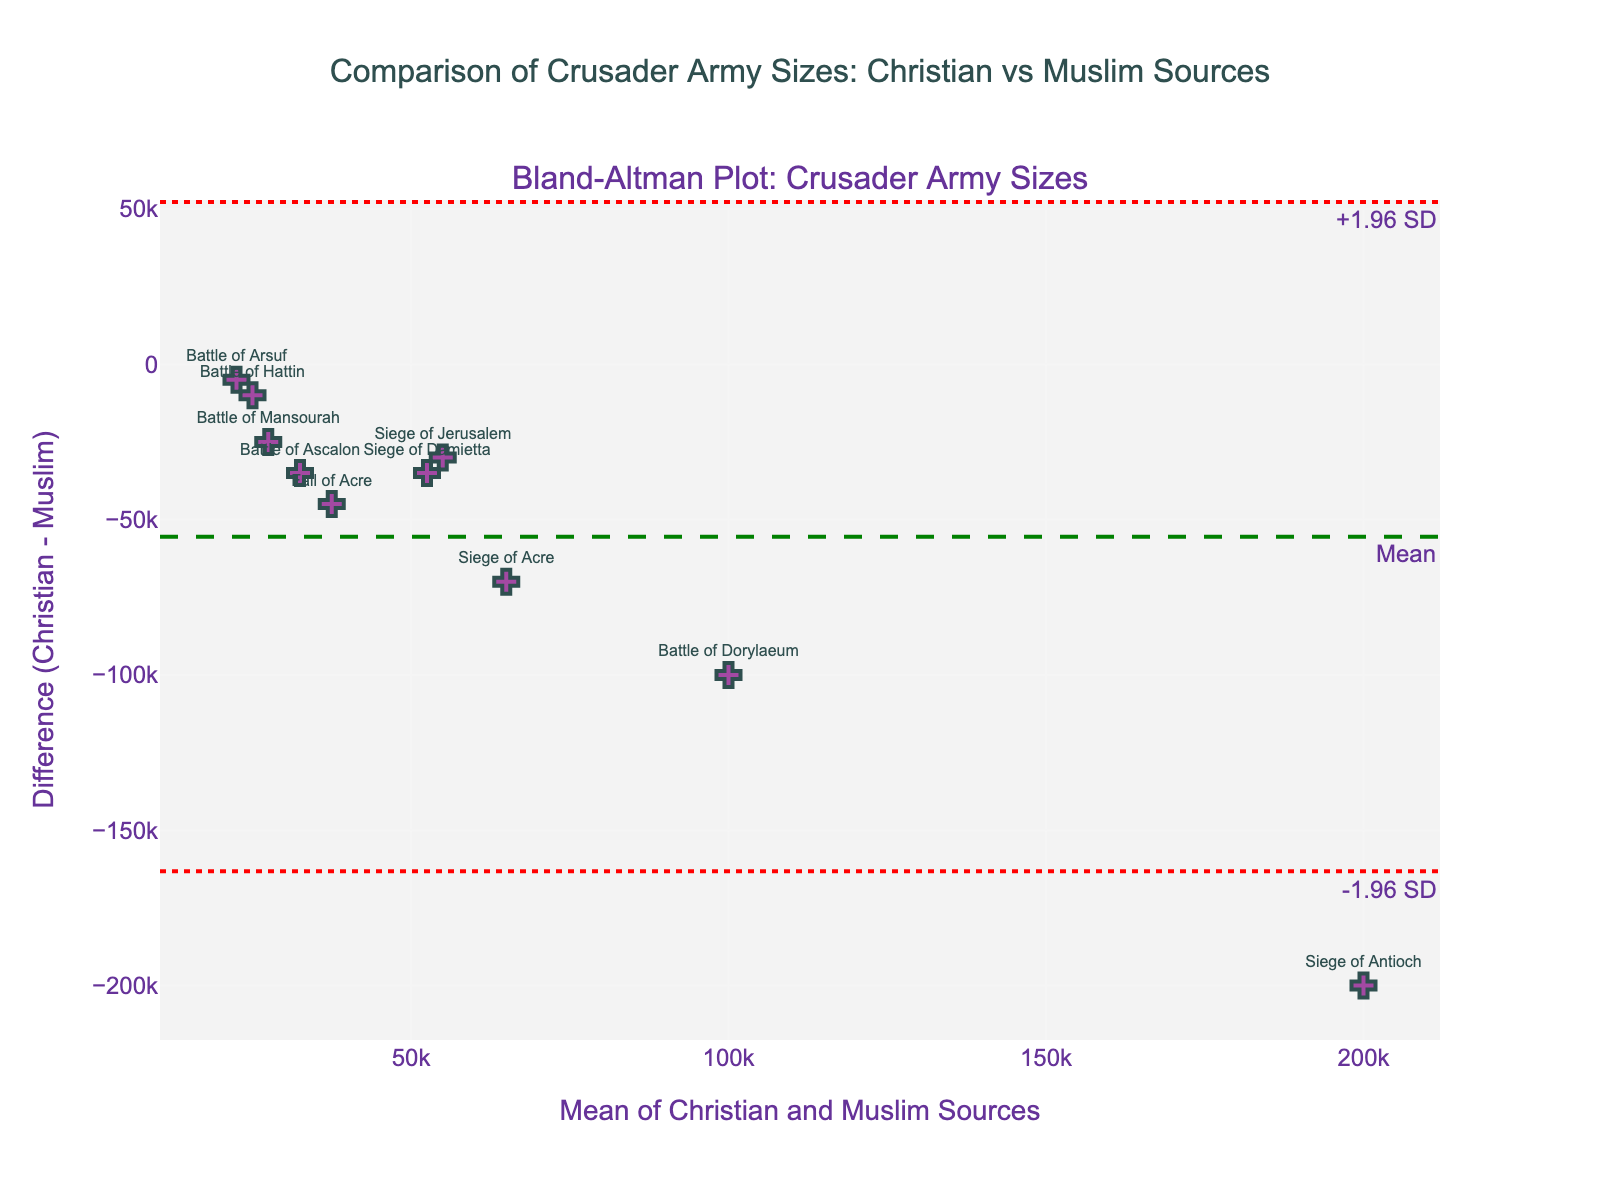how many battles are represented in the plot? To determine the number of battles, count the number of distinct markers on the plot. Each marker represents a different battle.
Answer: 10 what is the title of the plot? The title is displayed at the top of the plot. Read and note the exact text shown there.
Answer: Comparison of Crusader Army Sizes: Christian vs Muslim Sources which battle has the highest mean of army sizes according to the plot? Identify the marker with the highest x-value, which represents the mean army sizes for the battles.
Answer: Siege of Antioch what is the range of the differences (Christian - Muslim) in army sizes? To find the range, determine the maximum and minimum y-values on the plot, representing the differences. Subtract the smallest y-value from the largest y-value.
Answer: -200,000 to -35,000 what is the mean difference (Christian - Muslim) according to the plot? Look for the horizontal line labeled "Mean" on the plot. The y-value of this line is the mean difference.
Answer: -87,000 which battle has the smallest difference in army sizes between Christian and Muslim sources? Identify the marker that is closest to the y=0 line, as it represents the smallest difference.
Answer: Battle of Arsuf which two battles have the most similar mean of army sizes? Compare the x-values of the markers and identify the two that are closest to each other.
Answer: Battle of Hattin and Siege of Jerusalem (both around 55,000) how many battles fall outside the limits of agreement? Determine the number of markers that fall outside the horizontal lines labeled "+1.96 SD" and "-1.96 SD".
Answer: 2 (Siege of Antioch and Battle of Dorylaeum) is the mean difference greater or smaller than zero? Check the position of the mean difference line relative to the y=0 line. If the mean difference line is below y=0, it's smaller; if it's above, it's greater.
Answer: Smaller what is the upper limit of agreement (+1.96 SD) value on the plot? Locate the horizontal line labeled "+1.96 SD" and read its y-value.
Answer: -40,840 